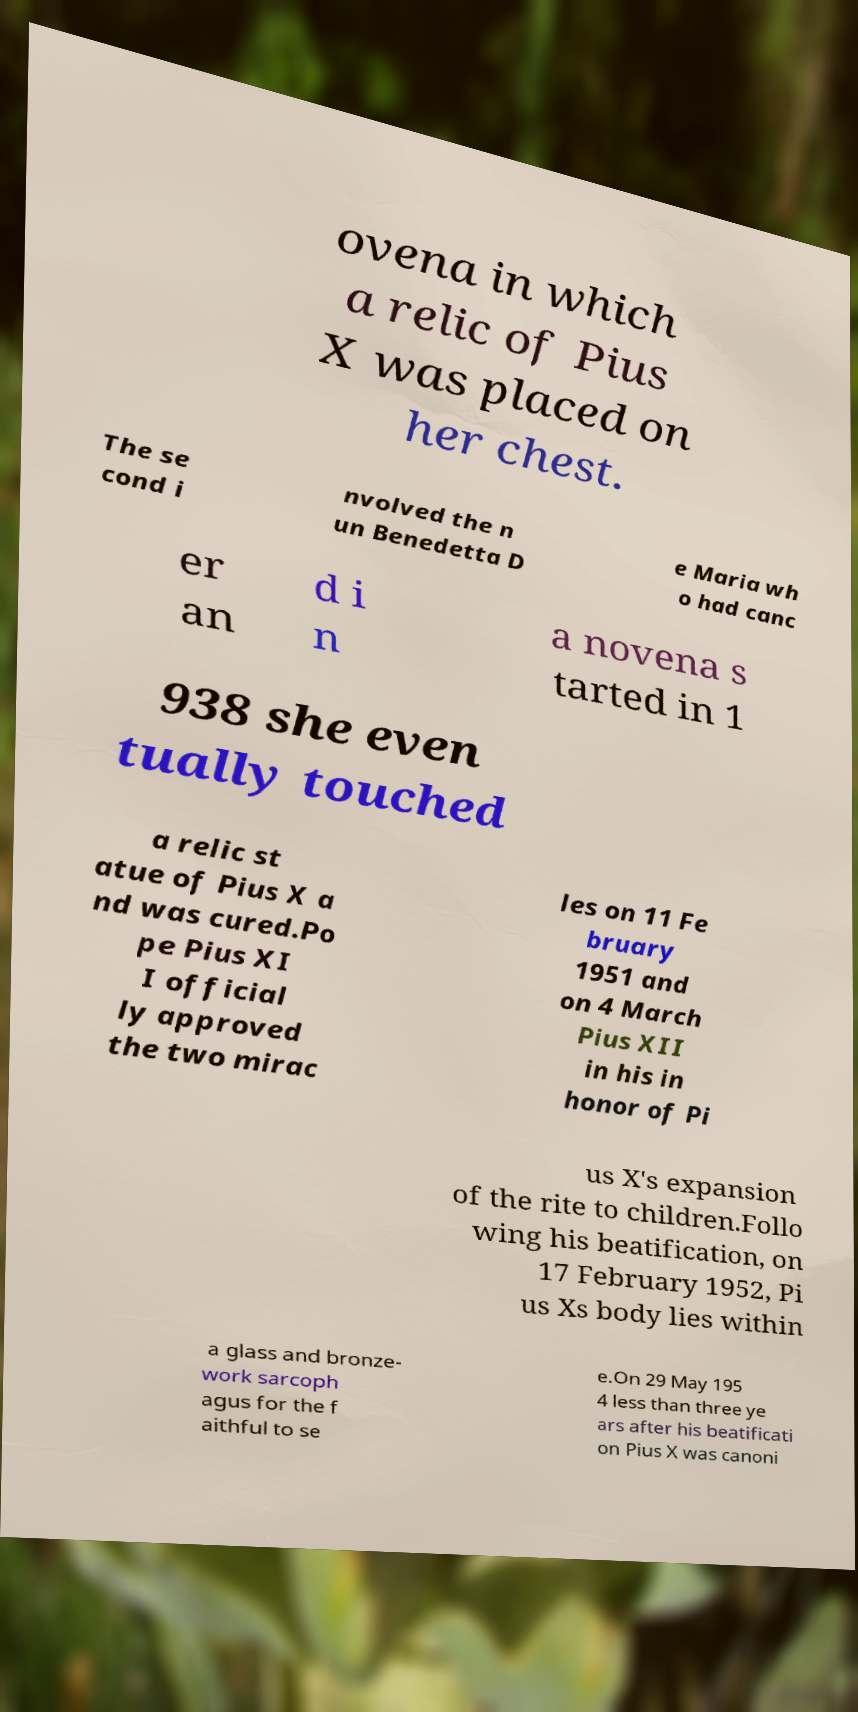Could you assist in decoding the text presented in this image and type it out clearly? ovena in which a relic of Pius X was placed on her chest. The se cond i nvolved the n un Benedetta D e Maria wh o had canc er an d i n a novena s tarted in 1 938 she even tually touched a relic st atue of Pius X a nd was cured.Po pe Pius XI I official ly approved the two mirac les on 11 Fe bruary 1951 and on 4 March Pius XII in his in honor of Pi us X's expansion of the rite to children.Follo wing his beatification, on 17 February 1952, Pi us Xs body lies within a glass and bronze- work sarcoph agus for the f aithful to se e.On 29 May 195 4 less than three ye ars after his beatificati on Pius X was canoni 